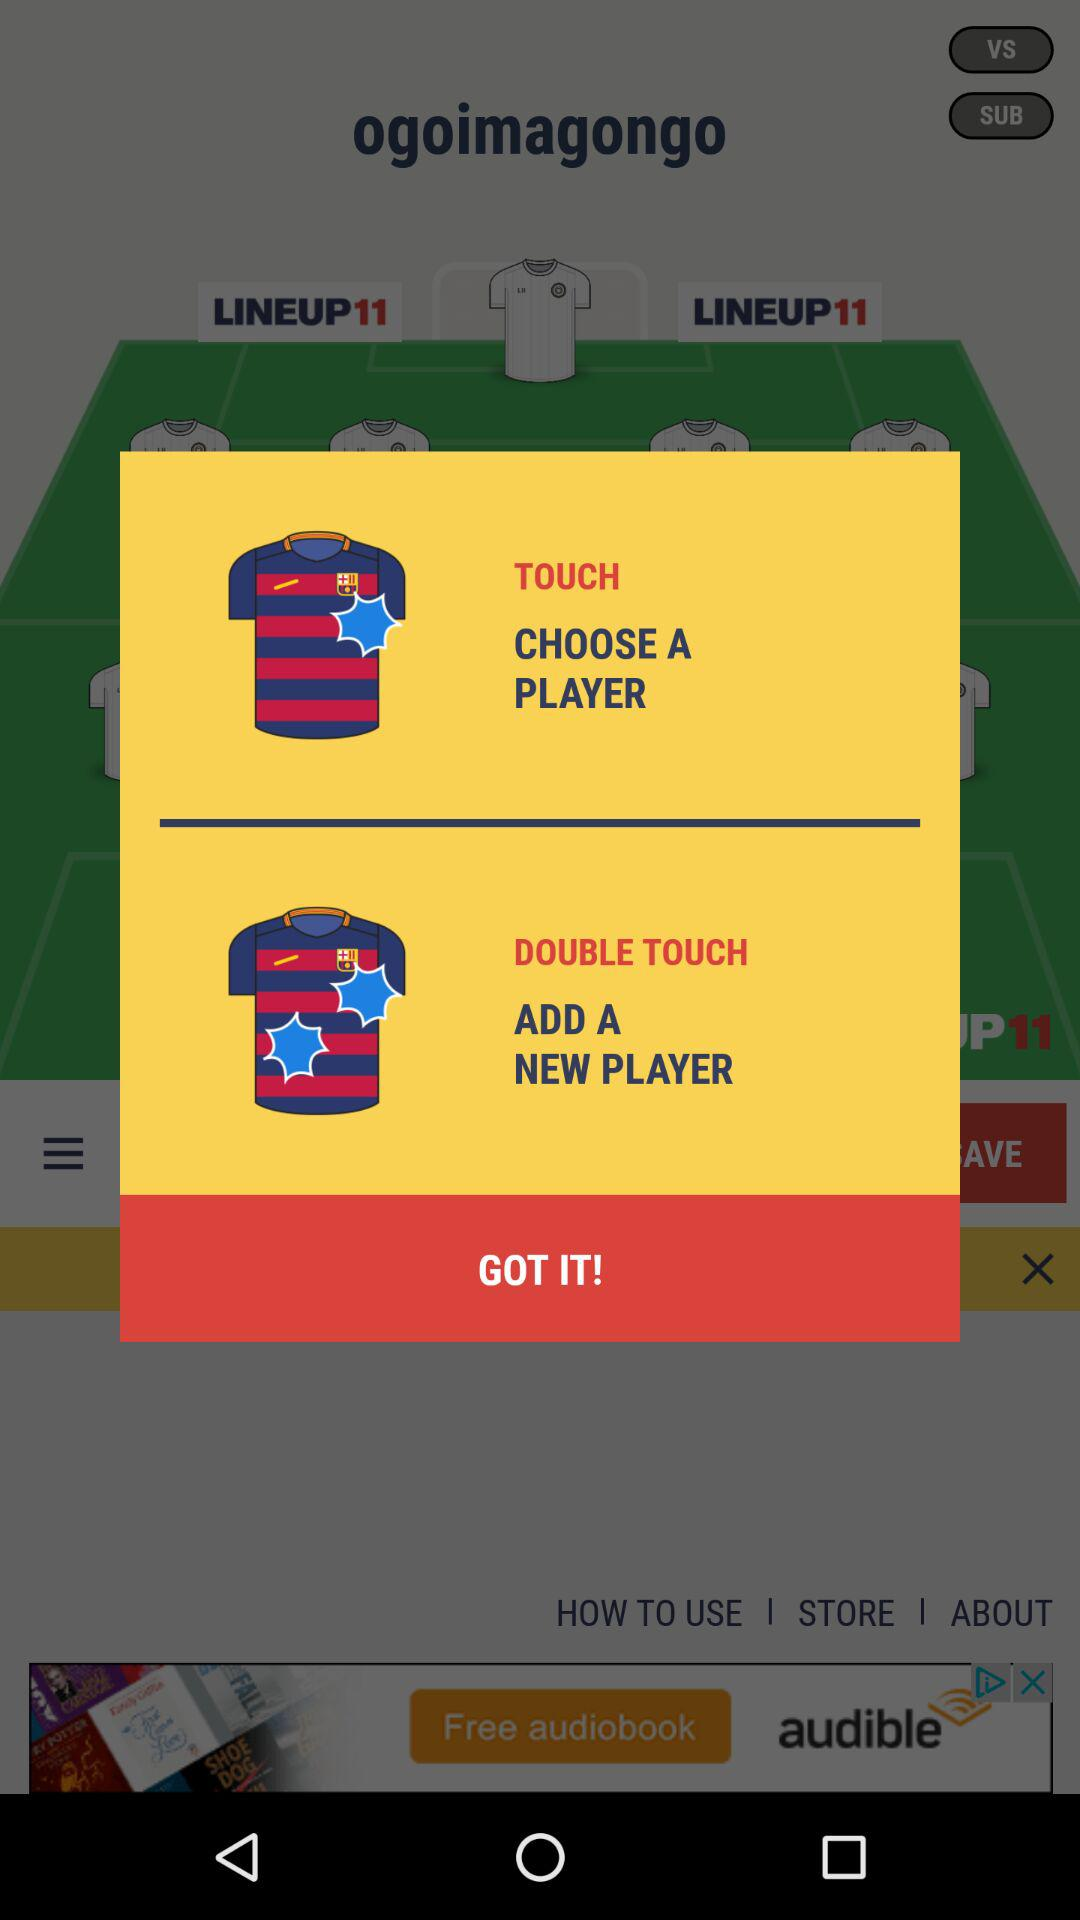What should I do to add the new player? You should double-touch to add the new player. 